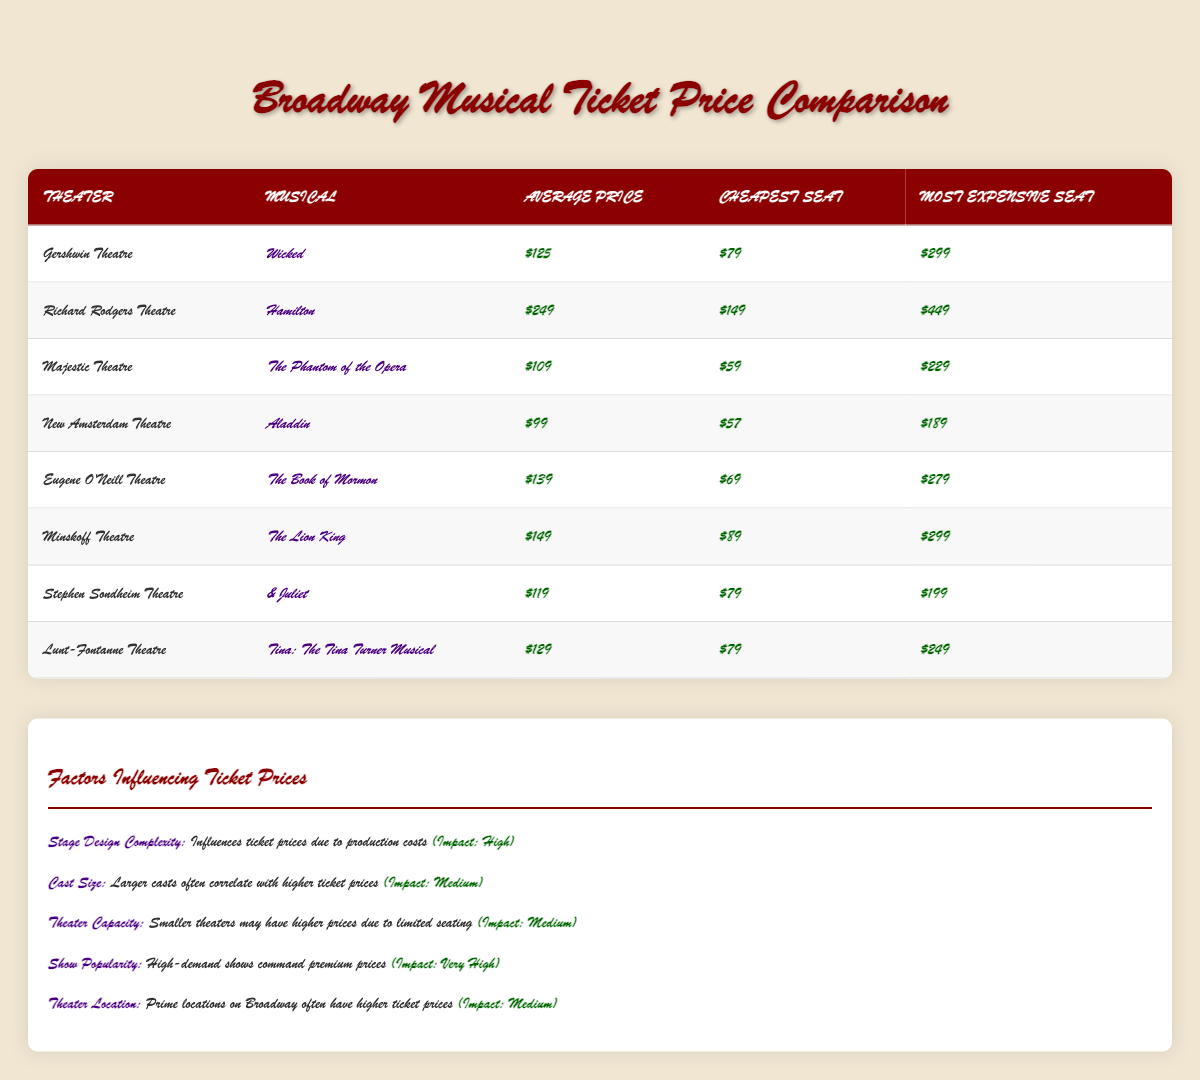What is the average ticket price for "Wicked"? The average ticket price for "Wicked," which is performed at the Gershwin Theatre, is listed in the table as $125.
Answer: 125 Which musical has the highest average ticket price? From the table, "Hamilton" at the Richard Rodgers Theatre has the highest average ticket price of $249.
Answer: Hamilton What is the difference in price between the cheapest and most expensive seat for "The Lion King"? For "The Lion King," the cheapest seat is $89 and the most expensive seat is $299. The difference is calculated as 299 - 89 = 210.
Answer: 210 Is the average ticket price for "The Phantom of the Opera" higher than $100? The average ticket price for "The Phantom of the Opera" is $109, which is indeed higher than $100.
Answer: Yes Which theater offers the cheapest ticket overall? The cheapest seat price is found at the New Amsterdam Theatre for "Aladdin" at $57, making it the theater with the cheapest ticket overall.
Answer: New Amsterdam Theatre What is the average price of all the musicals listed in the table? To find the average, sum all average ticket prices: 125 + 249 + 109 + 99 + 139 + 149 + 119 + 129 = 1118. There are 8 musicals, so the average is 1118 / 8 = 139.75.
Answer: 139.75 Has any musical's cheapest ticket price reached below $60? By reviewing the table, "The Phantom of the Opera" has the cheapest seat at $59, which is indeed below $60.
Answer: Yes Which musical has the largest price range between the cheapest and most expensive seat? The price range for each musical can be calculated: for "Hamilton," it's 449 - 149 = 300; for "The Lion King," it's 299 - 89 = 210; and for "The Book of Mormon," it's 279 - 69 = 210. "Hamilton" has the largest range of 300.
Answer: Hamilton 